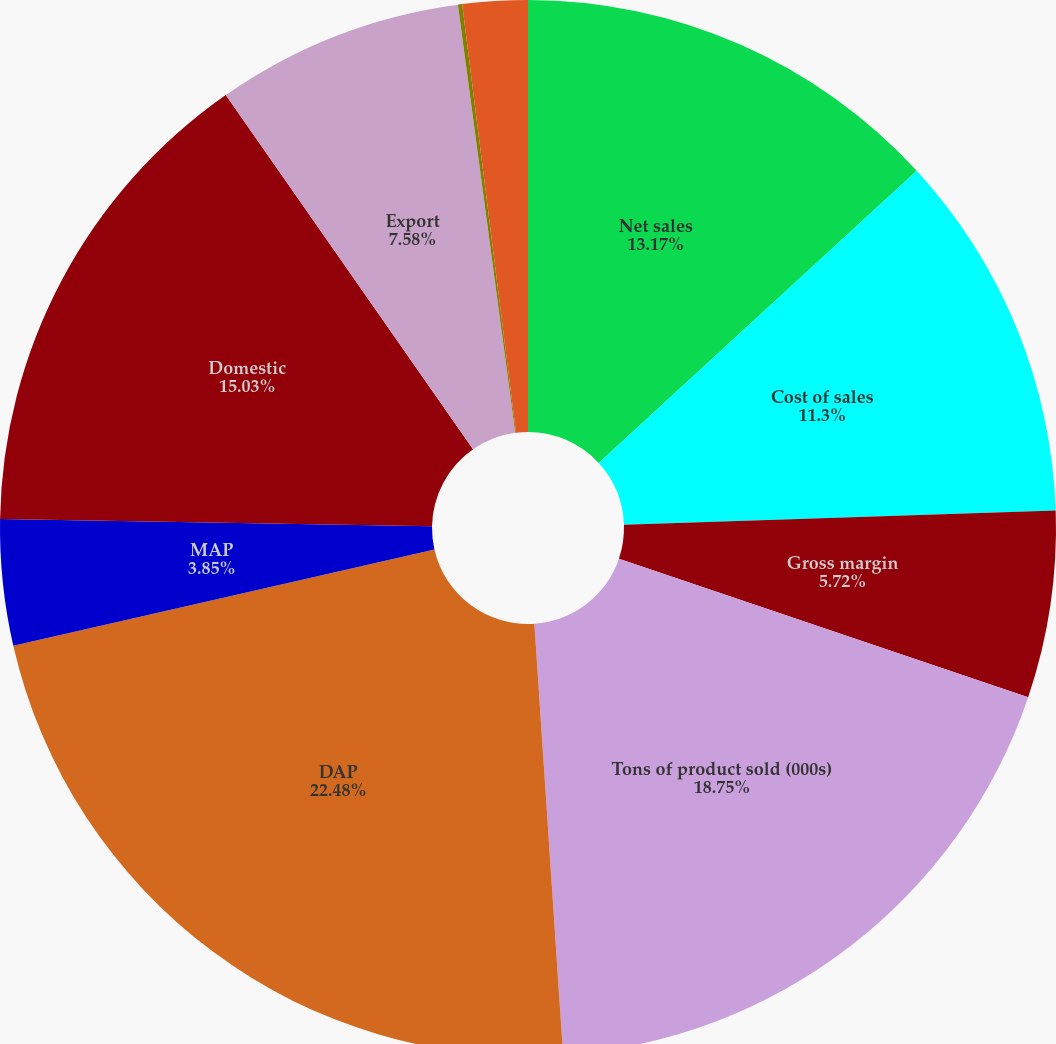Convert chart. <chart><loc_0><loc_0><loc_500><loc_500><pie_chart><fcel>Net sales<fcel>Cost of sales<fcel>Gross margin<fcel>Tons of product sold (000s)<fcel>DAP<fcel>MAP<fcel>Domestic<fcel>Export<fcel>Depreciation depletion and<fcel>Capital expenditures<nl><fcel>13.17%<fcel>11.3%<fcel>5.72%<fcel>18.75%<fcel>22.48%<fcel>3.85%<fcel>15.03%<fcel>7.58%<fcel>0.13%<fcel>1.99%<nl></chart> 